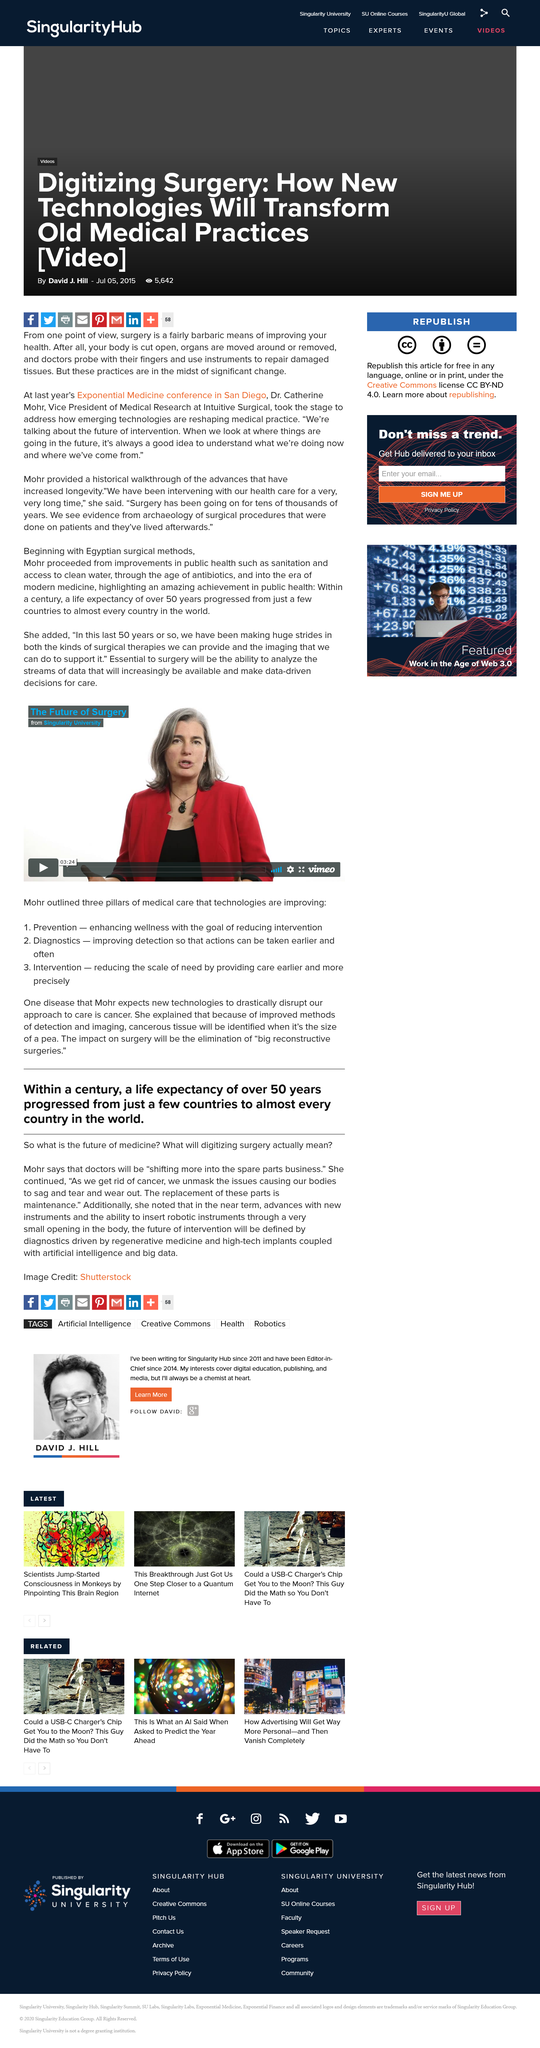Draw attention to some important aspects in this diagram. The replacement of parts described as maintenance is necessary for proper functioning of the machine. It took over a century for life expectancy to increase by more than 50 years in nearly all countries. The speaker identified three pillars of medical care during their presentation. The life expectancy in nearly every country is over 50 years. The presentation is entitled 'The Future of Surgery' and the speaker is Mohr. 